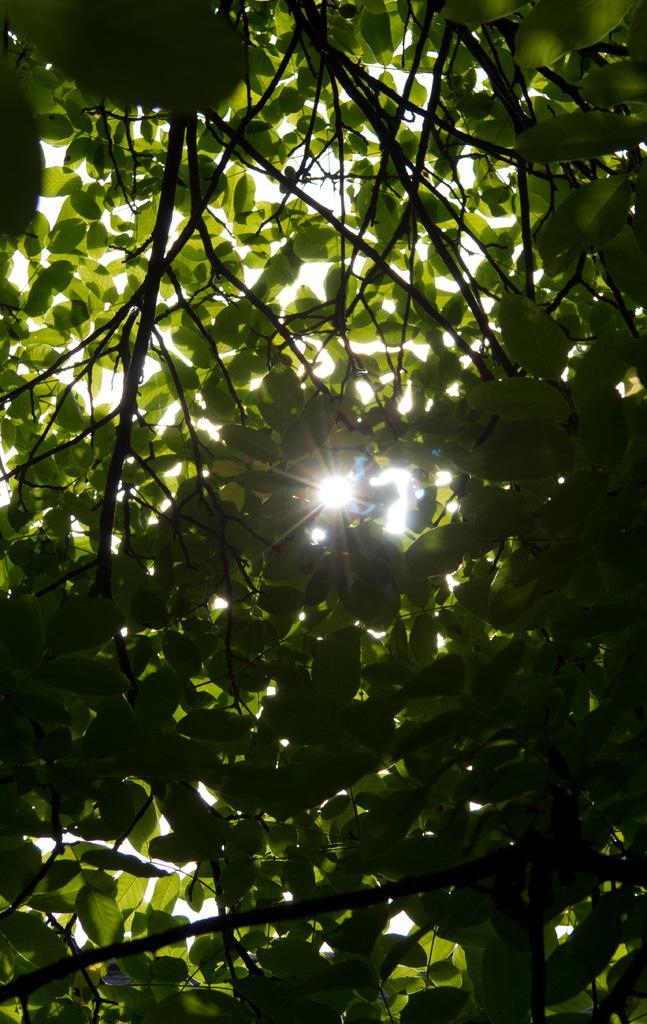Can you describe this image briefly? In this image I can see few trees in green color and I can see the sun and the sky. 